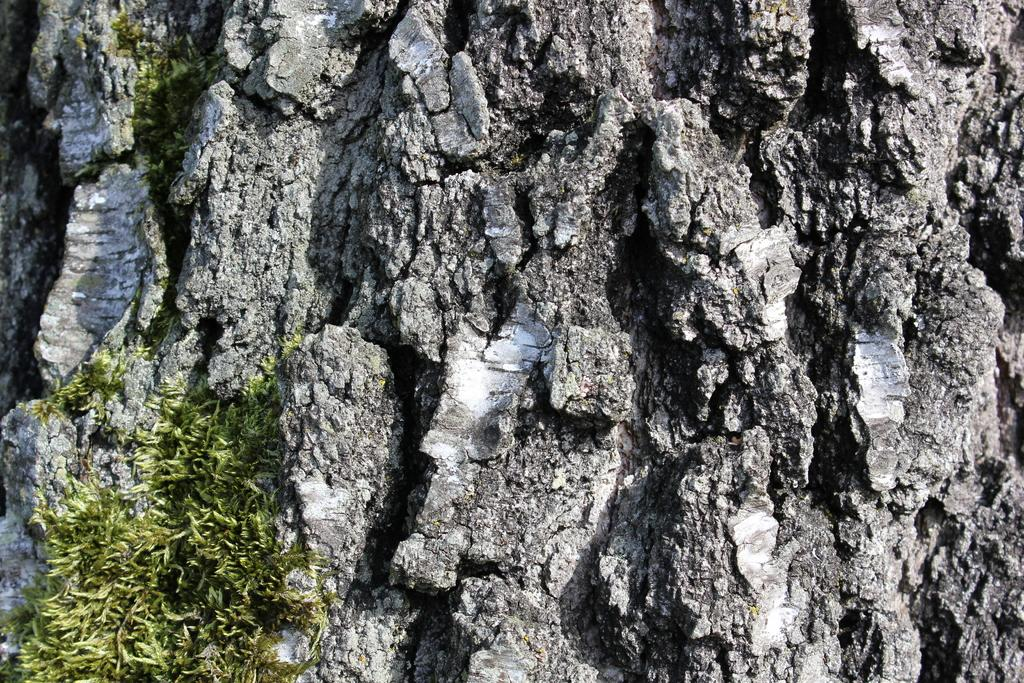What is the main subject of the image? The main subject of the image is a rock. Are there any specific features on the rock? Yes, the rock has cracks on it. What type of vegetation is present on the rock? There is grass on the rock. Can you tell me how many strangers are standing on the rock in the image? There are no strangers present in the image; it only features a rock with cracks and grass. What type of mineral is the rock made of, specifically quartz? The facts provided do not mention the composition of the rock, so it cannot be determined if it is made of quartz. 